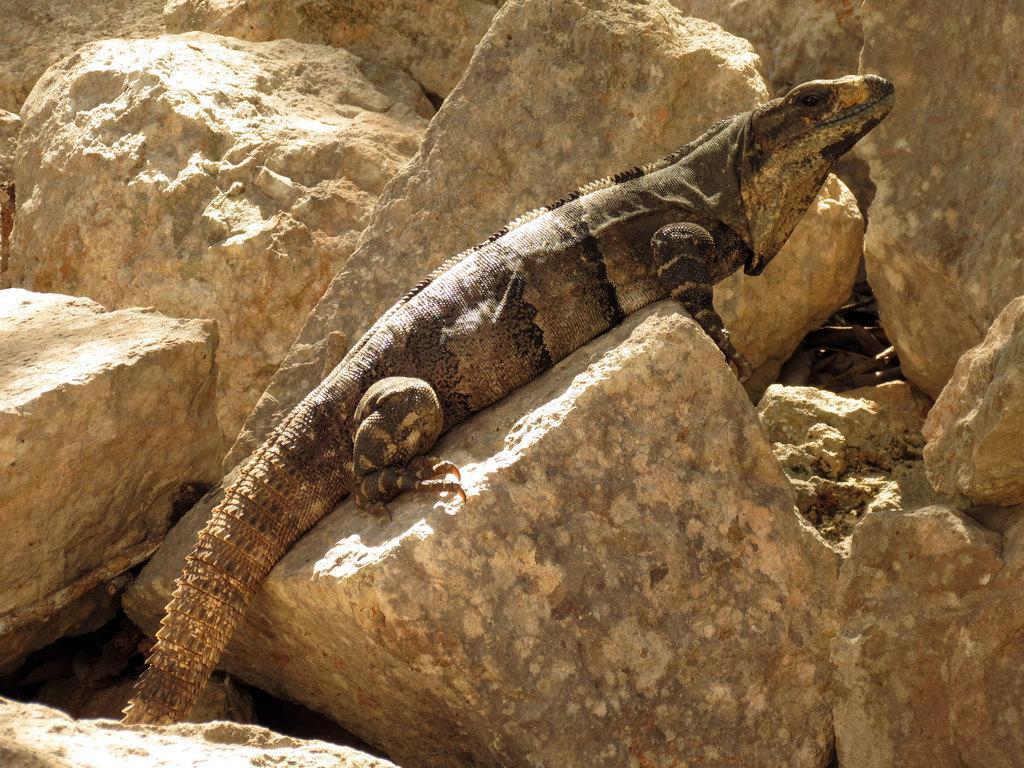In one or two sentences, can you explain what this image depicts? In this image we can see a reptile on the rock. We can also see some rocks around it. 